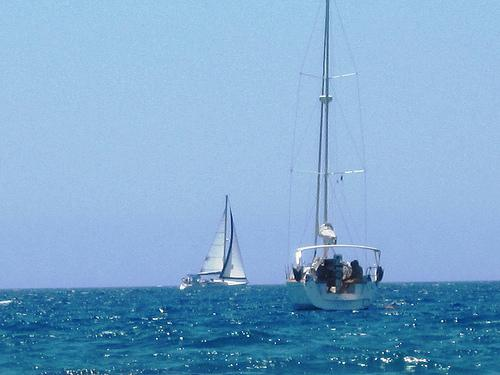Question: what is this?
Choices:
A. An ocean scene.
B. A lakeside.
C. A mountain scene.
D. The desert.
Answer with the letter. Answer: A Question: who is in the picture?
Choices:
A. Animals.
B. No one.
C. People.
D. Policemen.
Answer with the letter. Answer: C Question: what are they doing?
Choices:
A. Going for a boat ride.
B. Going for a car ride.
C. Going for a plane ride.
D. Going for a bus ride.
Answer with the letter. Answer: A Question: when was picture taken?
Choices:
A. During nighttime.
B. During daylight.
C. During twilight.
D. During daybreak.
Answer with the letter. Answer: B Question: what is condition of sky?
Choices:
A. Cloudy.
B. Dark.
C. Rainy.
D. Clear.
Answer with the letter. Answer: D Question: how many boats are there?
Choices:
A. 2.
B. 1.
C. 3.
D. 4.
Answer with the letter. Answer: A Question: where is the sail small sailboat?
Choices:
A. In front of other boat.
B. In back of the other boat.
C. Beside the other boat.
D. Near the shore.
Answer with the letter. Answer: A Question: why is sail not up on one boat?
Choices:
A. It is broken.
B. It is anchored.
C. It is not windy.
D. It is not a sailboat.
Answer with the letter. Answer: B 